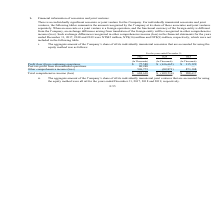According to United Micro Electronics's financial document, Is there a  individually significant associate or joint venture for the Company? There is no individually significant associate or joint venture for the Company.. The document states: "There is no individually significant associate or joint venture for the Company. For individually immaterial associates and joint ventures, the follow..." Also, What is recognized as comprehensive income (loss)? an exchange difference arising from translation of the foreign entity will be recognized in other comprehensive income (loss).. The document states: "the foreign entity is different from the Company, an exchange difference arising from translation of the foreign entity will be recognized in other co..." Also, What method is used to calculate the aggregate amount of the Company’s share? According to the financial document, the equity method. The relevant text states: "mmaterial associates that are accounted for using the equity method was as follows:..." Also, can you calculate: What is the average Profit (loss) from continuing operations? To answer this question, I need to perform calculations using the financial data. The calculation is: (77,589+616,665+115,329) / 3, which equals 269861 (in thousands). This is based on the information: "from continuing operations $ 77,589 $ (616,665) $ 115,329 Post-tax profit from discontinued operations 80,248 — — Other comprehensive income (loss) 526,773 ( fit (loss) from continuing operations $ 77..." The key data points involved are: 115,329, 616,665, 77,589. Also, can you calculate: What is the increase/ (decrease) in Total comprehensive income (loss) from 2018 to 2019? Based on the calculation: 988,637-699,536, the result is 289101 (in thousands). This is based on the information: "08 Total comprehensive income (loss) $ 684,610 $ (699,536) $ 988,637 mprehensive income (loss) $ 684,610 $ (699,536) $ 988,637..." The key data points involved are: 699,536, 988,637. Also, can you calculate: What is the increase/ (decrease) in Profit (loss) from continuing operations from 2018 to 2019? Based on the calculation: 115,329-616,665, the result is -501336 (in thousands). This is based on the information: "from continuing operations $ 77,589 $ (616,665) $ 115,329 Post-tax profit from discontinued operations 80,248 — — Other comprehensive income (loss) 526,773 ( fit (loss) from continuing operations $ 77..." The key data points involved are: 115,329, 616,665. 